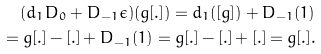<formula> <loc_0><loc_0><loc_500><loc_500>( d _ { 1 } D _ { 0 } + D _ { - 1 } \epsilon ) ( g [ . ] ) = d _ { 1 } ( [ g ] ) + D _ { - 1 } ( 1 ) \\ = g [ . ] - [ . ] + D _ { - 1 } ( 1 ) = g [ . ] - [ . ] + [ . ] = g [ . ] .</formula> 